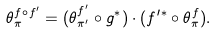Convert formula to latex. <formula><loc_0><loc_0><loc_500><loc_500>\theta ^ { f \circ f ^ { \prime } } _ { \pi } = ( \theta ^ { f ^ { \prime } } _ { \pi ^ { \prime } } \circ g ^ { \ast } ) \cdot ( f ^ { \prime \ast } \circ \theta ^ { f } _ { \pi } ) .</formula> 